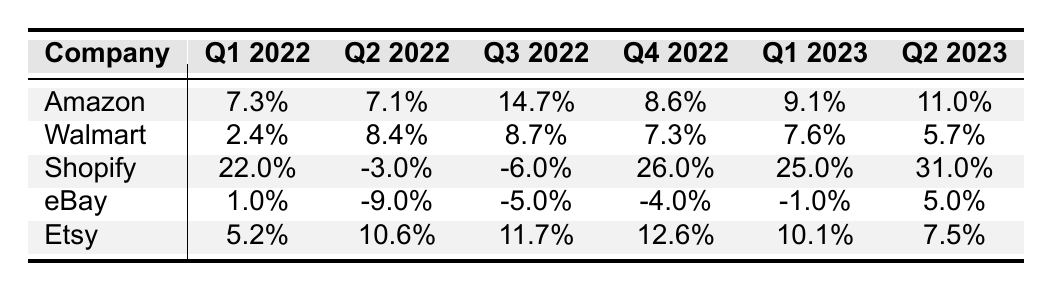What was Shopify's revenue growth in Q1 2023? Referring to the table, Shopify's revenue growth in Q1 2023 is listed directly under that column, which shows a value of 25.0%.
Answer: 25.0% Which company had the highest revenue growth in Q3 2022? Looking at the Q3 2022 column, Shopify has the highest revenue growth at -6.0%, as all other companies are lower.
Answer: Shopify What is the average revenue growth of Etsy across all reported quarters? Summing up Etsy's revenue growth values (5.2 + 10.6 + 11.7 + 12.6 + 10.1 + 7.5 = 57.7) and dividing by the number of quarters (6), we find the average growth is 57.7/6 = 9.62%.
Answer: 9.62% Did eBay experience any positive revenue growth in Q4 2022? In the table, the value for eBay's revenue growth in Q4 2022 is -4.0%, which is negative. Therefore, eBay did not have positive revenue growth in that quarter.
Answer: No What was the overall trend for Amazon's revenue growth from Q1 2022 to Q2 2023? Looking at Amazon's values from Q1 2022 (7.3%) to Q2 2023 (11.0%), we see an upward movement, showing that Amazon's revenue growth increased over this period.
Answer: Increasing What company had the least revenue growth in Q2 2023? Referring to the Q2 2023 column, Walmart shows the least revenue growth at 5.7%, compared to other companies listed in that column.
Answer: Walmart Which competitor had a negative revenue growth in Q2 2022? Checking the Q2 2022 column, only Shopify reports a negative growth of -3.0%, while all other companies have positive growth values.
Answer: Shopify What was the difference in revenue growth between Amazon and Etsy in Q1 2023? Amazon's revenue growth in Q1 2023 is 9.1% and Etsy's is 10.1%. Calculating the difference gives us 10.1 - 9.1 = 1.0%.
Answer: 1.0% Was there any quarter where Shopify had negative revenue growth? Yes, Shopify had negative growth in Q2 2022 (-3.0%) and Q3 2022 (-6.0%), as indicated in the table under those respective quarters.
Answer: Yes What is the cumulative revenue growth of Walmart across all quarters? Summing Walmart's growth values (2.4 + 8.4 + 8.7 + 7.3 + 7.6 + 5.7 = 40.1) gives us a cumulative total of 40.1%.
Answer: 40.1% 